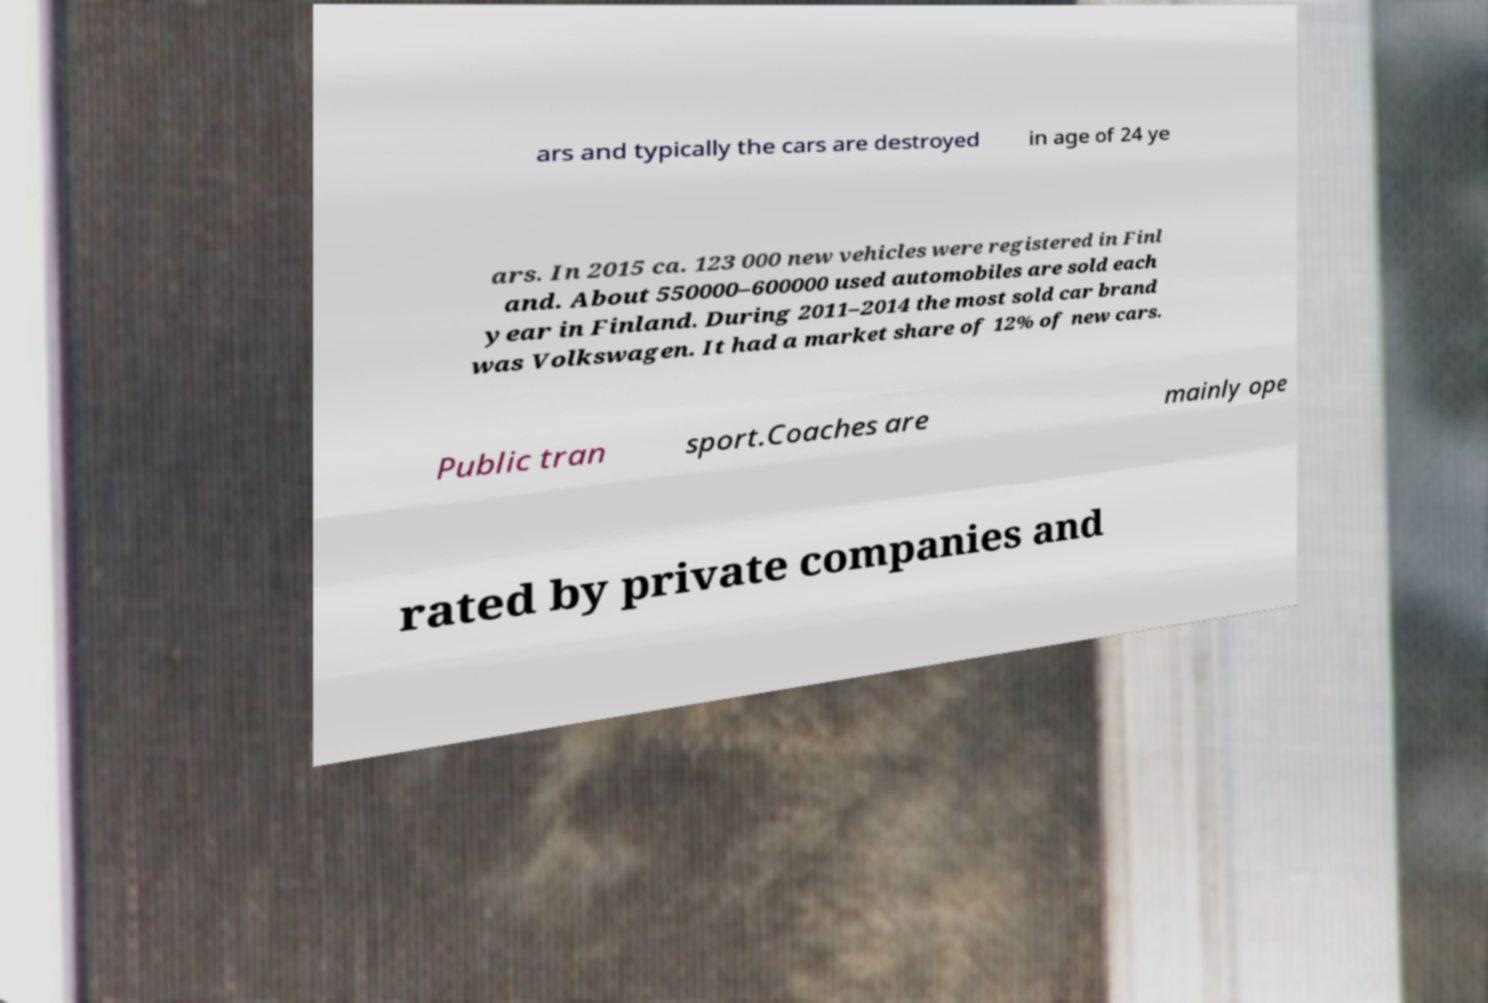There's text embedded in this image that I need extracted. Can you transcribe it verbatim? ars and typically the cars are destroyed in age of 24 ye ars. In 2015 ca. 123 000 new vehicles were registered in Finl and. About 550000–600000 used automobiles are sold each year in Finland. During 2011–2014 the most sold car brand was Volkswagen. It had a market share of 12% of new cars. Public tran sport.Coaches are mainly ope rated by private companies and 